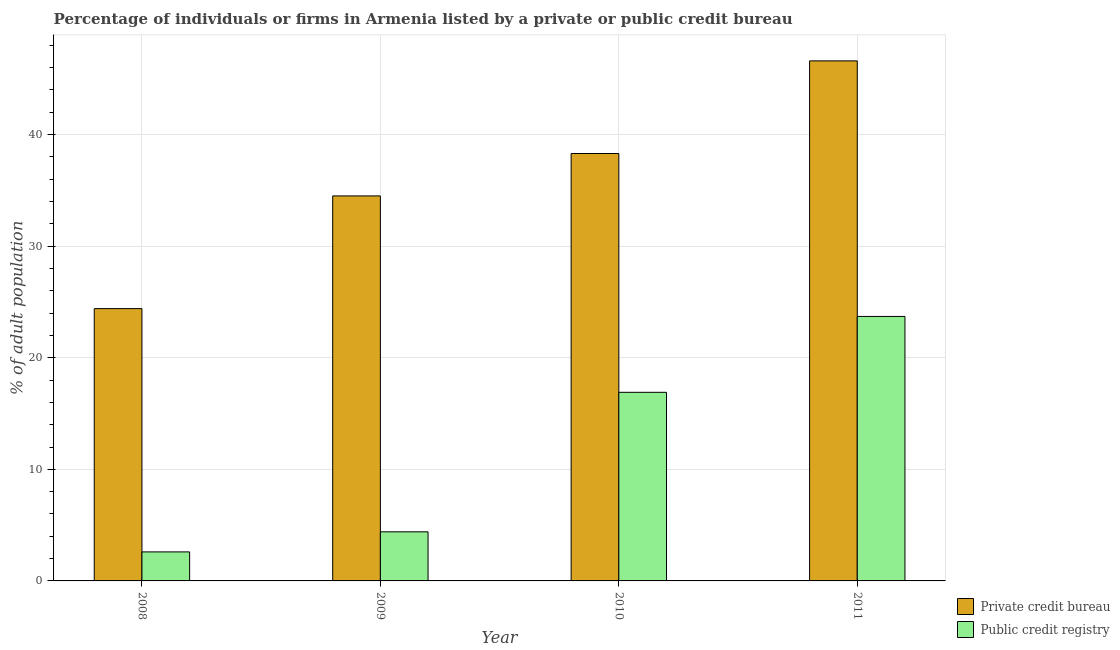How many different coloured bars are there?
Offer a very short reply. 2. Are the number of bars on each tick of the X-axis equal?
Make the answer very short. Yes. How many bars are there on the 2nd tick from the left?
Your response must be concise. 2. In how many cases, is the number of bars for a given year not equal to the number of legend labels?
Offer a terse response. 0. What is the percentage of firms listed by private credit bureau in 2008?
Give a very brief answer. 24.4. Across all years, what is the maximum percentage of firms listed by private credit bureau?
Offer a very short reply. 46.6. In which year was the percentage of firms listed by public credit bureau minimum?
Make the answer very short. 2008. What is the total percentage of firms listed by public credit bureau in the graph?
Provide a short and direct response. 47.6. What is the difference between the percentage of firms listed by public credit bureau in 2009 and that in 2010?
Keep it short and to the point. -12.5. What is the difference between the percentage of firms listed by private credit bureau in 2009 and the percentage of firms listed by public credit bureau in 2008?
Ensure brevity in your answer.  10.1. What is the average percentage of firms listed by private credit bureau per year?
Make the answer very short. 35.95. In the year 2010, what is the difference between the percentage of firms listed by public credit bureau and percentage of firms listed by private credit bureau?
Provide a short and direct response. 0. What is the ratio of the percentage of firms listed by public credit bureau in 2009 to that in 2011?
Give a very brief answer. 0.19. Is the percentage of firms listed by public credit bureau in 2009 less than that in 2011?
Ensure brevity in your answer.  Yes. Is the difference between the percentage of firms listed by private credit bureau in 2008 and 2010 greater than the difference between the percentage of firms listed by public credit bureau in 2008 and 2010?
Provide a short and direct response. No. What is the difference between the highest and the second highest percentage of firms listed by public credit bureau?
Keep it short and to the point. 6.8. What is the difference between the highest and the lowest percentage of firms listed by private credit bureau?
Make the answer very short. 22.2. In how many years, is the percentage of firms listed by private credit bureau greater than the average percentage of firms listed by private credit bureau taken over all years?
Ensure brevity in your answer.  2. Is the sum of the percentage of firms listed by private credit bureau in 2009 and 2011 greater than the maximum percentage of firms listed by public credit bureau across all years?
Your answer should be compact. Yes. What does the 1st bar from the left in 2010 represents?
Your response must be concise. Private credit bureau. What does the 2nd bar from the right in 2011 represents?
Provide a succinct answer. Private credit bureau. How many bars are there?
Provide a succinct answer. 8. Are all the bars in the graph horizontal?
Ensure brevity in your answer.  No. Are the values on the major ticks of Y-axis written in scientific E-notation?
Provide a succinct answer. No. How many legend labels are there?
Offer a terse response. 2. How are the legend labels stacked?
Provide a short and direct response. Vertical. What is the title of the graph?
Ensure brevity in your answer.  Percentage of individuals or firms in Armenia listed by a private or public credit bureau. What is the label or title of the X-axis?
Offer a terse response. Year. What is the label or title of the Y-axis?
Provide a succinct answer. % of adult population. What is the % of adult population of Private credit bureau in 2008?
Keep it short and to the point. 24.4. What is the % of adult population in Public credit registry in 2008?
Offer a terse response. 2.6. What is the % of adult population of Private credit bureau in 2009?
Your answer should be very brief. 34.5. What is the % of adult population of Public credit registry in 2009?
Provide a succinct answer. 4.4. What is the % of adult population in Private credit bureau in 2010?
Ensure brevity in your answer.  38.3. What is the % of adult population in Public credit registry in 2010?
Ensure brevity in your answer.  16.9. What is the % of adult population in Private credit bureau in 2011?
Your answer should be very brief. 46.6. What is the % of adult population in Public credit registry in 2011?
Ensure brevity in your answer.  23.7. Across all years, what is the maximum % of adult population of Private credit bureau?
Keep it short and to the point. 46.6. Across all years, what is the maximum % of adult population of Public credit registry?
Keep it short and to the point. 23.7. Across all years, what is the minimum % of adult population in Private credit bureau?
Make the answer very short. 24.4. What is the total % of adult population of Private credit bureau in the graph?
Your response must be concise. 143.8. What is the total % of adult population of Public credit registry in the graph?
Offer a very short reply. 47.6. What is the difference between the % of adult population in Public credit registry in 2008 and that in 2009?
Offer a terse response. -1.8. What is the difference between the % of adult population of Private credit bureau in 2008 and that in 2010?
Ensure brevity in your answer.  -13.9. What is the difference between the % of adult population in Public credit registry in 2008 and that in 2010?
Your answer should be compact. -14.3. What is the difference between the % of adult population of Private credit bureau in 2008 and that in 2011?
Keep it short and to the point. -22.2. What is the difference between the % of adult population of Public credit registry in 2008 and that in 2011?
Offer a very short reply. -21.1. What is the difference between the % of adult population of Private credit bureau in 2009 and that in 2010?
Provide a succinct answer. -3.8. What is the difference between the % of adult population of Public credit registry in 2009 and that in 2010?
Make the answer very short. -12.5. What is the difference between the % of adult population of Private credit bureau in 2009 and that in 2011?
Give a very brief answer. -12.1. What is the difference between the % of adult population in Public credit registry in 2009 and that in 2011?
Provide a succinct answer. -19.3. What is the difference between the % of adult population of Private credit bureau in 2010 and that in 2011?
Provide a succinct answer. -8.3. What is the difference between the % of adult population of Public credit registry in 2010 and that in 2011?
Provide a short and direct response. -6.8. What is the difference between the % of adult population in Private credit bureau in 2008 and the % of adult population in Public credit registry in 2009?
Make the answer very short. 20. What is the difference between the % of adult population of Private credit bureau in 2008 and the % of adult population of Public credit registry in 2010?
Provide a short and direct response. 7.5. What is the difference between the % of adult population in Private credit bureau in 2009 and the % of adult population in Public credit registry in 2011?
Make the answer very short. 10.8. What is the difference between the % of adult population of Private credit bureau in 2010 and the % of adult population of Public credit registry in 2011?
Provide a short and direct response. 14.6. What is the average % of adult population in Private credit bureau per year?
Offer a terse response. 35.95. In the year 2008, what is the difference between the % of adult population in Private credit bureau and % of adult population in Public credit registry?
Make the answer very short. 21.8. In the year 2009, what is the difference between the % of adult population in Private credit bureau and % of adult population in Public credit registry?
Provide a succinct answer. 30.1. In the year 2010, what is the difference between the % of adult population in Private credit bureau and % of adult population in Public credit registry?
Give a very brief answer. 21.4. In the year 2011, what is the difference between the % of adult population of Private credit bureau and % of adult population of Public credit registry?
Offer a very short reply. 22.9. What is the ratio of the % of adult population of Private credit bureau in 2008 to that in 2009?
Offer a terse response. 0.71. What is the ratio of the % of adult population of Public credit registry in 2008 to that in 2009?
Your answer should be compact. 0.59. What is the ratio of the % of adult population in Private credit bureau in 2008 to that in 2010?
Your answer should be compact. 0.64. What is the ratio of the % of adult population in Public credit registry in 2008 to that in 2010?
Ensure brevity in your answer.  0.15. What is the ratio of the % of adult population of Private credit bureau in 2008 to that in 2011?
Keep it short and to the point. 0.52. What is the ratio of the % of adult population of Public credit registry in 2008 to that in 2011?
Your response must be concise. 0.11. What is the ratio of the % of adult population of Private credit bureau in 2009 to that in 2010?
Provide a succinct answer. 0.9. What is the ratio of the % of adult population of Public credit registry in 2009 to that in 2010?
Provide a short and direct response. 0.26. What is the ratio of the % of adult population of Private credit bureau in 2009 to that in 2011?
Your answer should be very brief. 0.74. What is the ratio of the % of adult population of Public credit registry in 2009 to that in 2011?
Make the answer very short. 0.19. What is the ratio of the % of adult population of Private credit bureau in 2010 to that in 2011?
Your response must be concise. 0.82. What is the ratio of the % of adult population in Public credit registry in 2010 to that in 2011?
Give a very brief answer. 0.71. What is the difference between the highest and the lowest % of adult population in Private credit bureau?
Offer a terse response. 22.2. What is the difference between the highest and the lowest % of adult population in Public credit registry?
Provide a succinct answer. 21.1. 